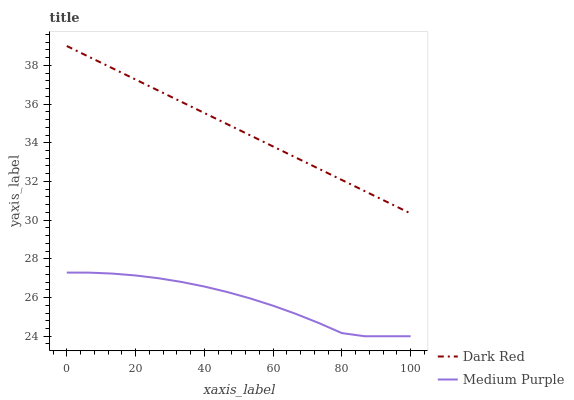Does Medium Purple have the minimum area under the curve?
Answer yes or no. Yes. Does Dark Red have the maximum area under the curve?
Answer yes or no. Yes. Does Dark Red have the minimum area under the curve?
Answer yes or no. No. Is Dark Red the smoothest?
Answer yes or no. Yes. Is Medium Purple the roughest?
Answer yes or no. Yes. Is Dark Red the roughest?
Answer yes or no. No. Does Dark Red have the lowest value?
Answer yes or no. No. Is Medium Purple less than Dark Red?
Answer yes or no. Yes. Is Dark Red greater than Medium Purple?
Answer yes or no. Yes. Does Medium Purple intersect Dark Red?
Answer yes or no. No. 